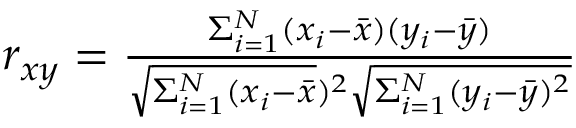<formula> <loc_0><loc_0><loc_500><loc_500>\begin{array} { r } { r _ { x y } = \frac { \Sigma _ { i = 1 } ^ { N } ( x _ { i } - \bar { x } ) ( y _ { i } - \bar { y } ) } { \sqrt { \Sigma _ { i = 1 } ^ { N } ( x _ { i } - \bar { x } } ) ^ { 2 } \sqrt { \Sigma _ { i = 1 } ^ { N } ( y _ { i } - \bar { y } ) ^ { 2 } } } } \end{array}</formula> 